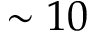<formula> <loc_0><loc_0><loc_500><loc_500>\sim 1 0</formula> 